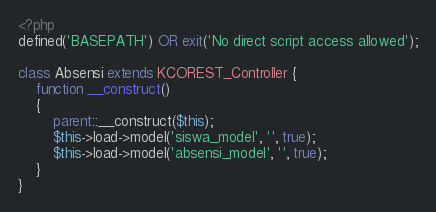<code> <loc_0><loc_0><loc_500><loc_500><_PHP_><?php
defined('BASEPATH') OR exit('No direct script access allowed');

class Absensi extends KCOREST_Controller {
	function __construct()
	{
		parent::__construct($this);
		$this->load->model('siswa_model', '', true);
		$this->load->model('absensi_model', '', true);
	}
}</code> 